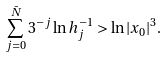<formula> <loc_0><loc_0><loc_500><loc_500>\sum _ { j = 0 } ^ { \bar { N } } 3 ^ { - j } \ln h ^ { - 1 } _ { j } > \ln | x _ { 0 } | ^ { 3 } .</formula> 